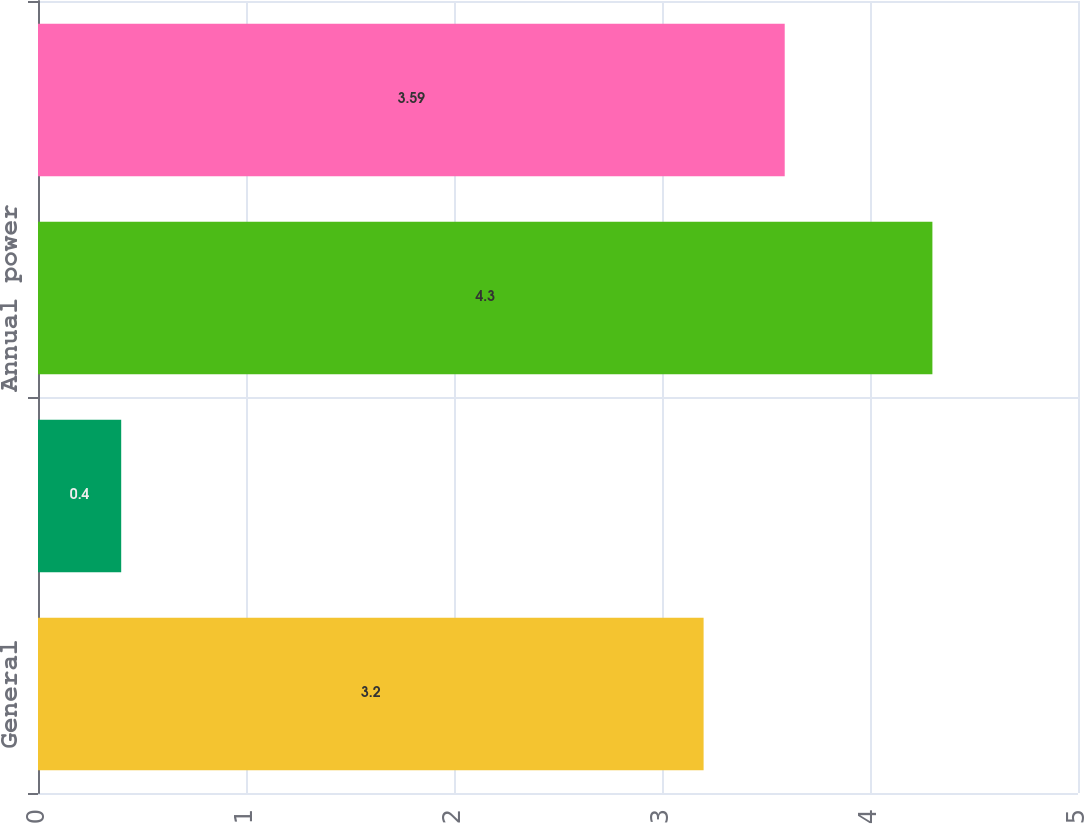<chart> <loc_0><loc_0><loc_500><loc_500><bar_chart><fcel>General<fcel>Apartment house<fcel>Annual power<fcel>Total Sales<nl><fcel>3.2<fcel>0.4<fcel>4.3<fcel>3.59<nl></chart> 